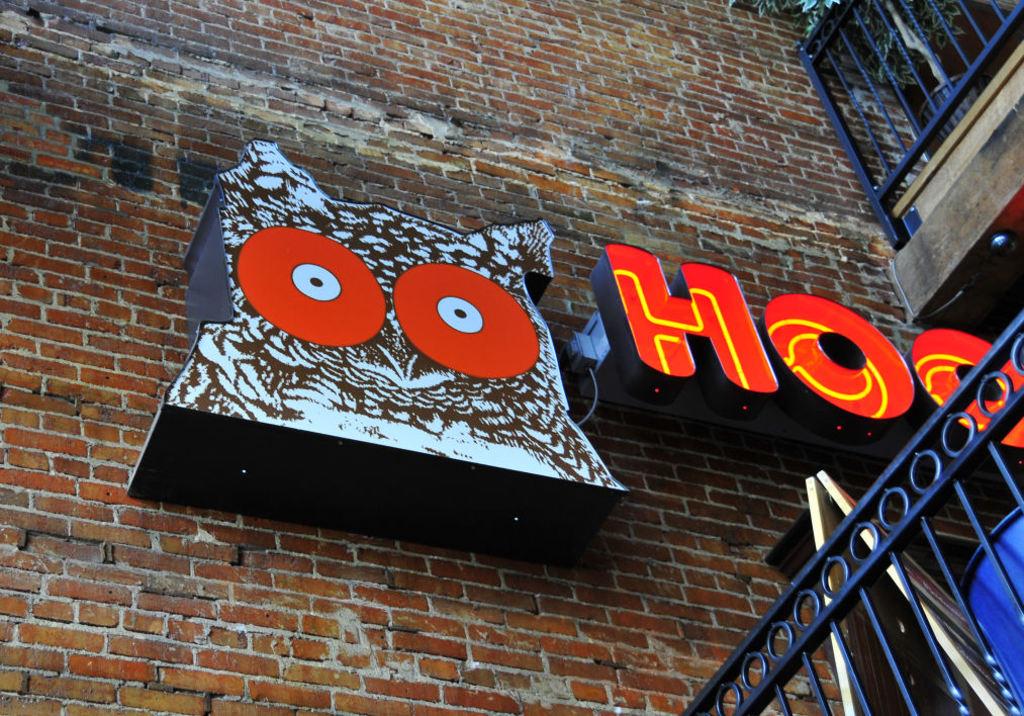Which letter of the alphabet is seen twice on the owl?
Offer a terse response. O. 